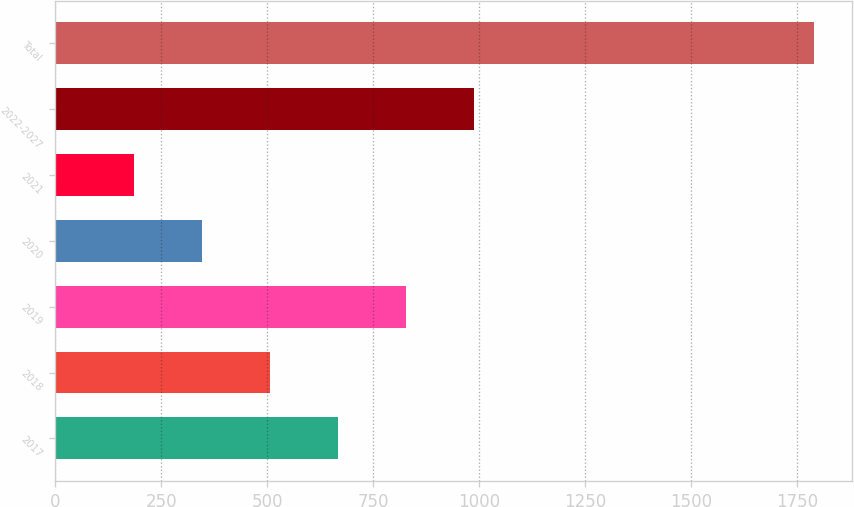Convert chart. <chart><loc_0><loc_0><loc_500><loc_500><bar_chart><fcel>2017<fcel>2018<fcel>2019<fcel>2020<fcel>2021<fcel>2022-2027<fcel>Total<nl><fcel>667.2<fcel>506.8<fcel>827.6<fcel>346.4<fcel>186<fcel>988<fcel>1790<nl></chart> 